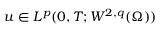Convert formula to latex. <formula><loc_0><loc_0><loc_500><loc_500>u \in L ^ { p } ( 0 , T ; W ^ { 2 , q } ( \Omega ) )</formula> 